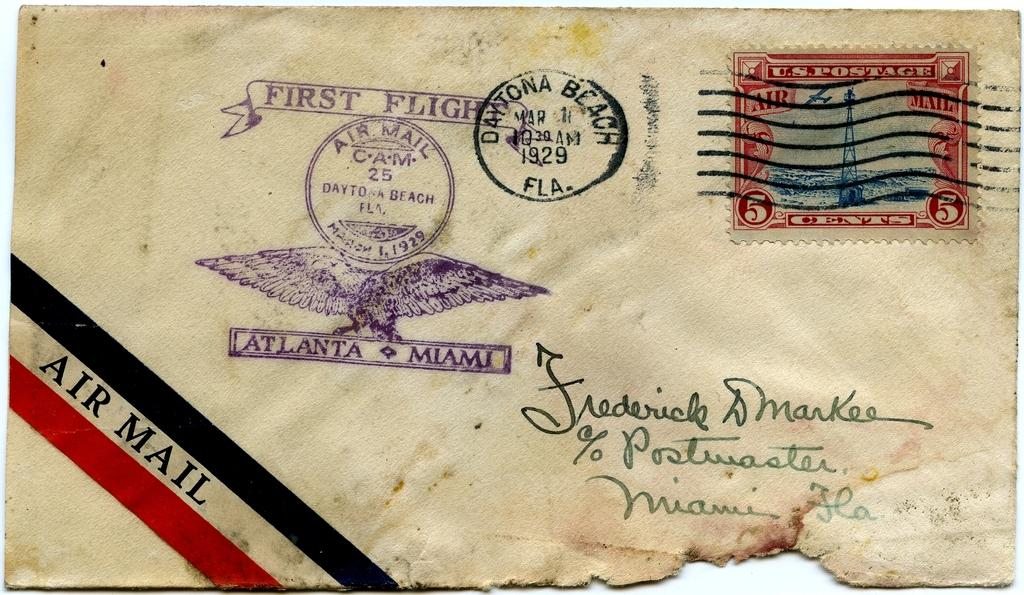<image>
Render a clear and concise summary of the photo. The envelope that was postmarked on March 1, 1929 was sent by air mail. 